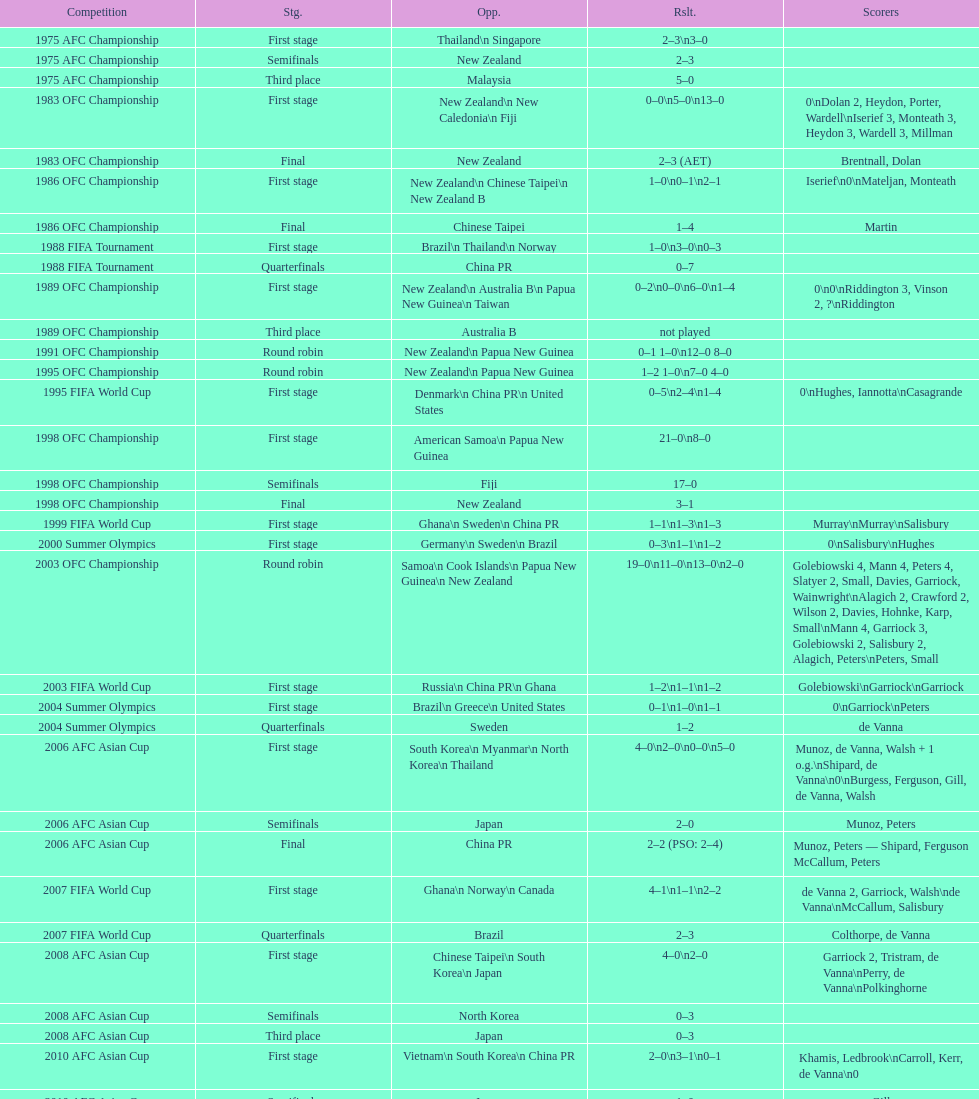Who was this team's next opponent after facing new zealand in the first stage of the 1986 ofc championship? Chinese Taipei. 